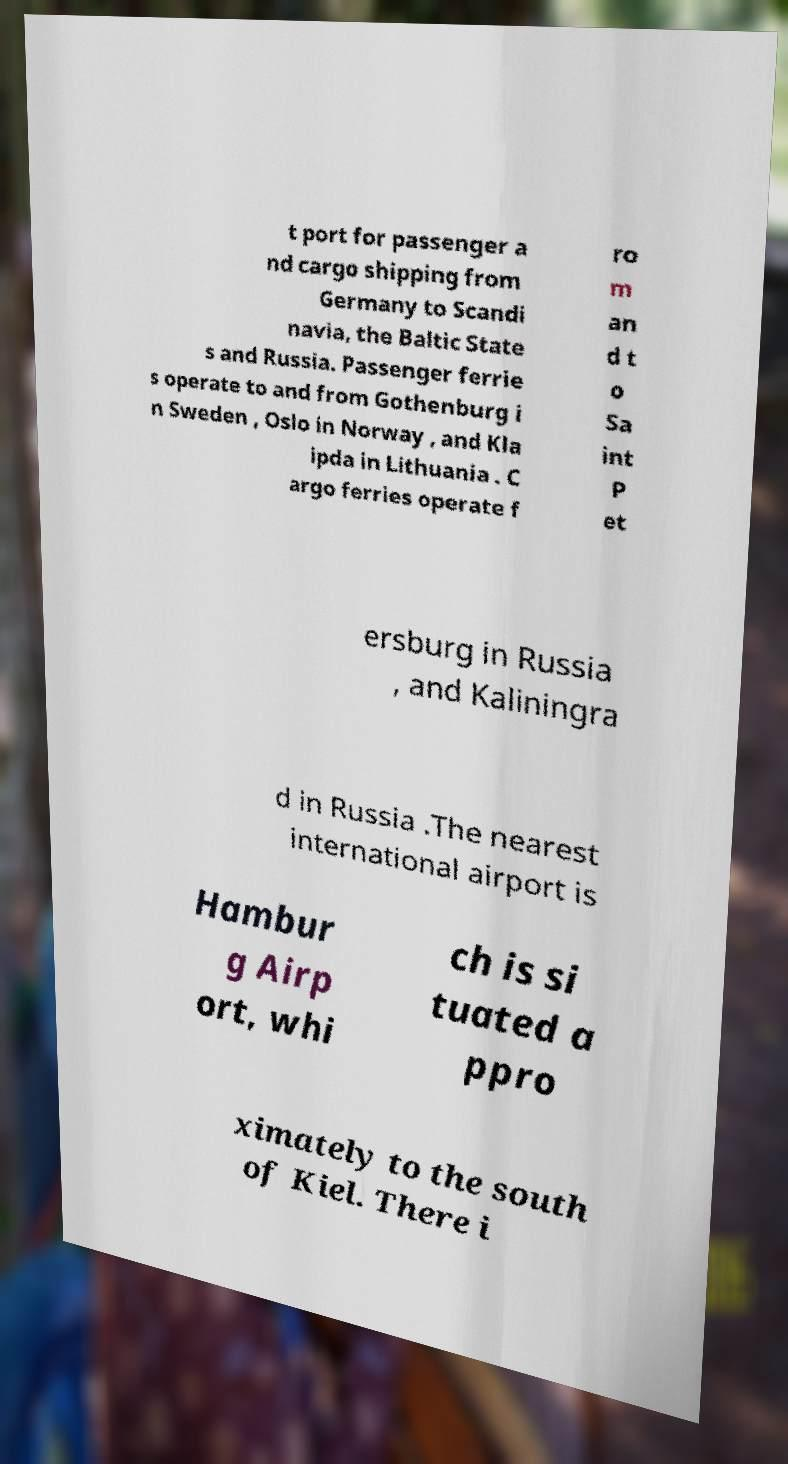Can you accurately transcribe the text from the provided image for me? t port for passenger a nd cargo shipping from Germany to Scandi navia, the Baltic State s and Russia. Passenger ferrie s operate to and from Gothenburg i n Sweden , Oslo in Norway , and Kla ipda in Lithuania . C argo ferries operate f ro m an d t o Sa int P et ersburg in Russia , and Kaliningra d in Russia .The nearest international airport is Hambur g Airp ort, whi ch is si tuated a ppro ximately to the south of Kiel. There i 